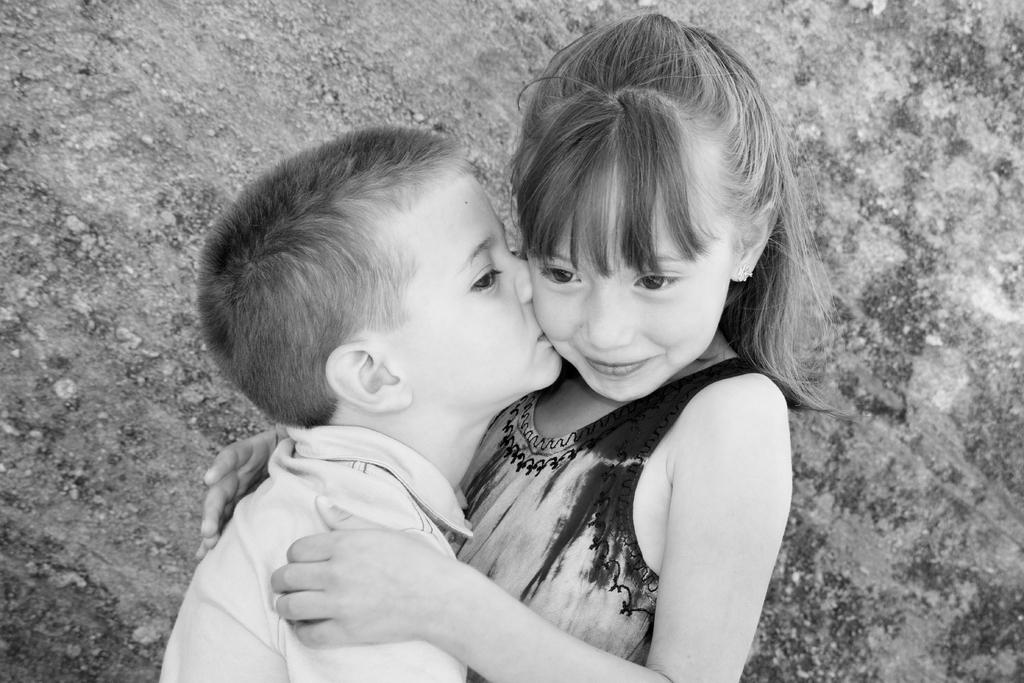What is the color scheme of the image? The image is black and white. How many people are in the image? There is a boy and a girl in the image. What is the boy doing in the image? The boy is kissing the girl. What is the girl's expression in the image? The girl is smiling. What type of boat can be seen in the image? There is no boat present in the image. What kind of stamp is visible on the girl's forehead in the image? There is no stamp on the girl's forehead in the image. 